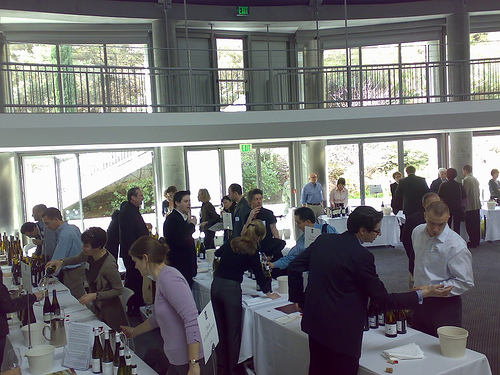<image>What color are the flowers? There are no flowers in the image. It can't be determined what color they are. What color are the flowers? It is not possible to determine the color of the flowers. 